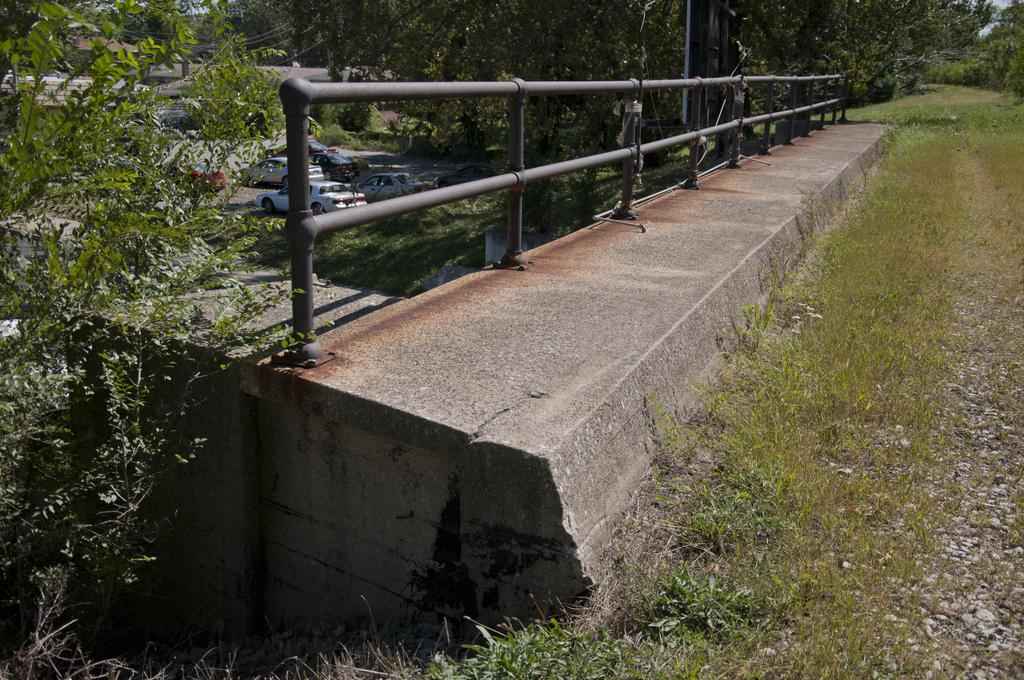What type of vegetation is present on the ground in the front of the image? There is grass on the ground in the front of the image. What can be seen in the front of the image besides the grass? There is a railing in the front of the image. What is located in the center of the image? There are cars and trees in the center of the image. What type of vegetation is present on the ground in the center of the image? There is grass on the ground in the center of the image. What type of soda is being served in the image? There is no soda present in the image. Is the grass hot to the touch in the image? The provided facts do not mention the temperature of the grass, so we cannot determine if it is hot or not. 